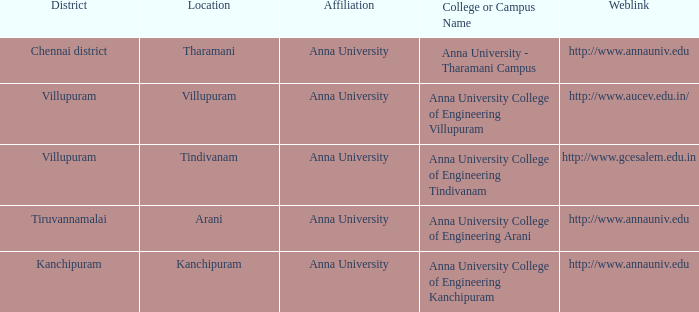In what district can one find a college or campus called anna university college of engineering kanchipuram? Kanchipuram. 